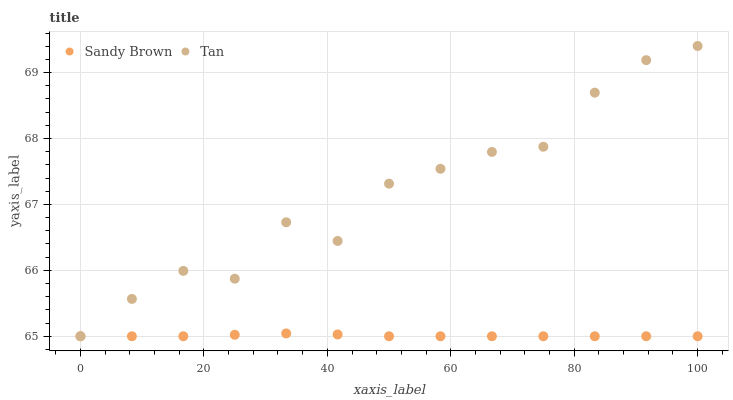Does Sandy Brown have the minimum area under the curve?
Answer yes or no. Yes. Does Tan have the maximum area under the curve?
Answer yes or no. Yes. Does Sandy Brown have the maximum area under the curve?
Answer yes or no. No. Is Sandy Brown the smoothest?
Answer yes or no. Yes. Is Tan the roughest?
Answer yes or no. Yes. Is Sandy Brown the roughest?
Answer yes or no. No. Does Tan have the lowest value?
Answer yes or no. Yes. Does Tan have the highest value?
Answer yes or no. Yes. Does Sandy Brown have the highest value?
Answer yes or no. No. Does Tan intersect Sandy Brown?
Answer yes or no. Yes. Is Tan less than Sandy Brown?
Answer yes or no. No. Is Tan greater than Sandy Brown?
Answer yes or no. No. 